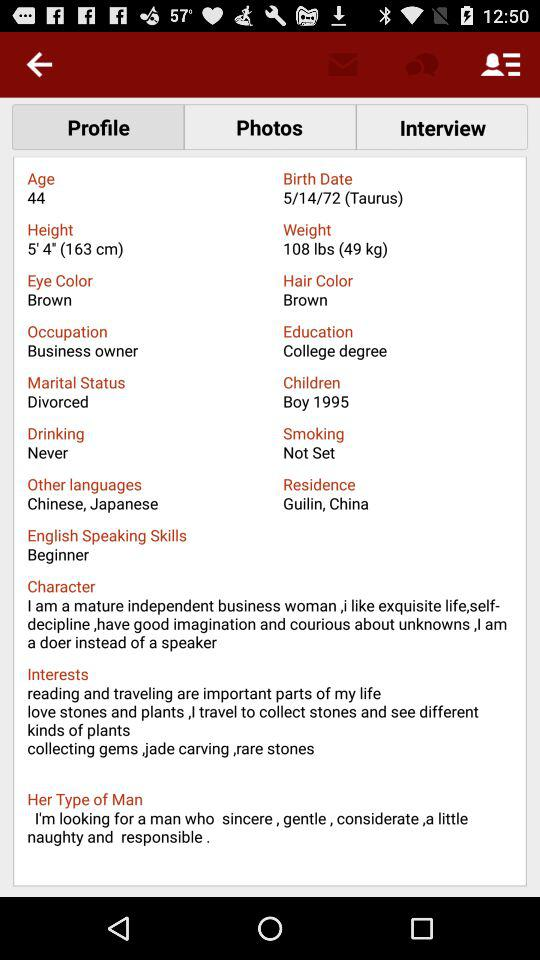What is the name of the application?
When the provided information is insufficient, respond with <no answer>. <no answer> 